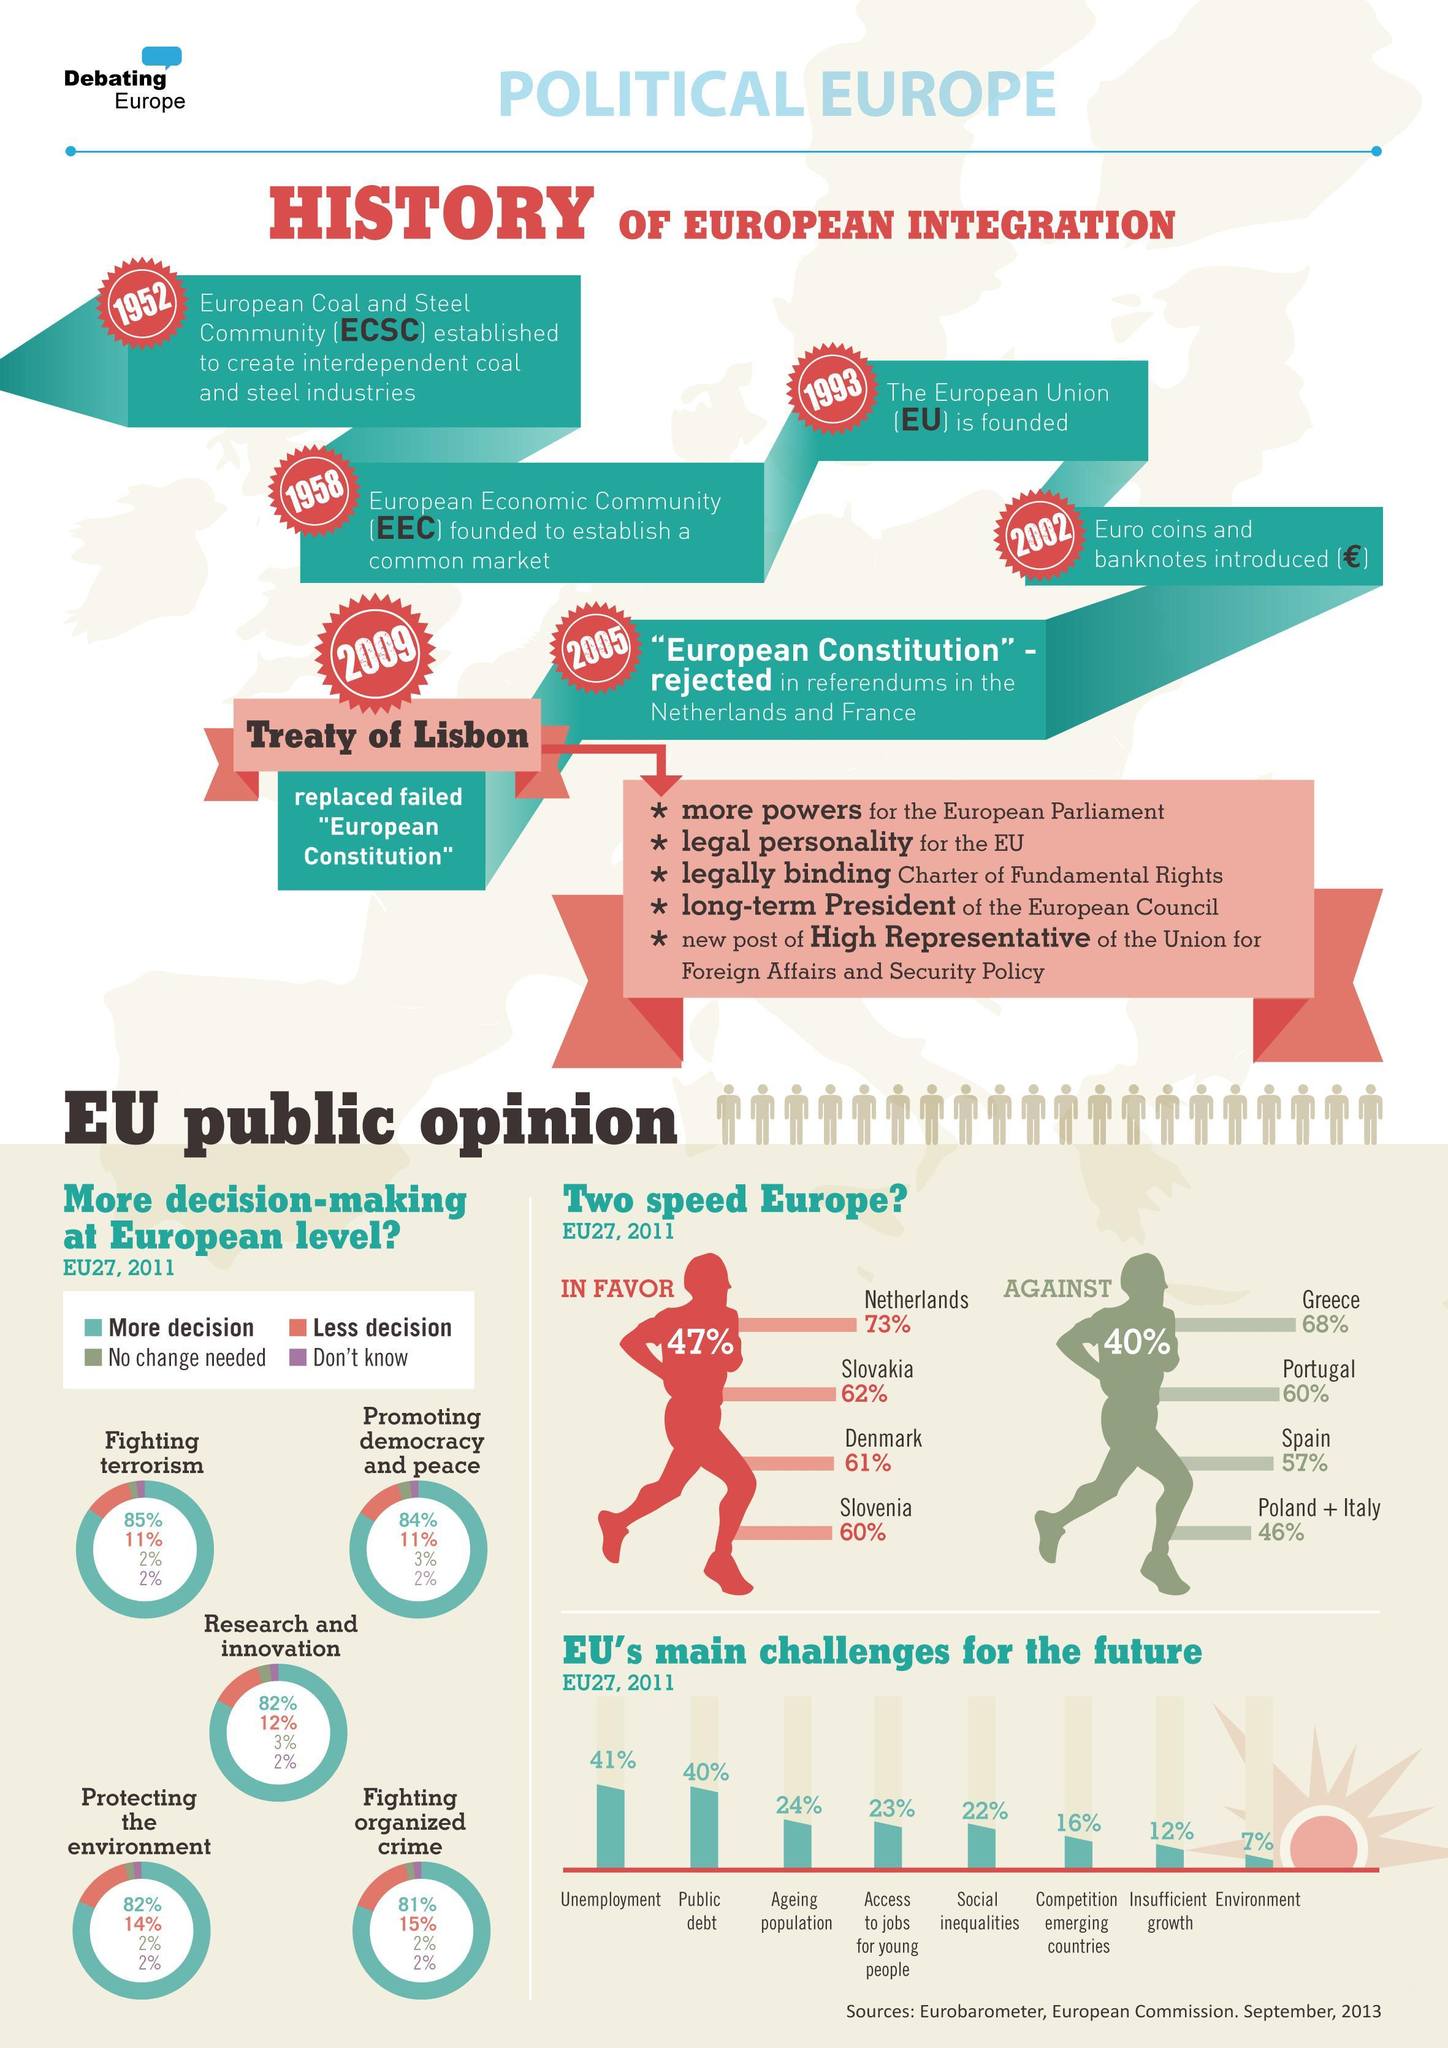How many points in the treaty of Lisbon
Answer the question with a short phrase. 5 What is the first two main challenges for EU for the future Unemployment, Public depot Along with Netherlands, which other countries were in favour of two speed Europe Slovakia, Denmark, Slovenia How many years after establishing the ECSC was the euro coins and bank notes introduced 50 In addition to Poland + Italy, which countries were against the two speed Europe Greece, Portugal, Spain When was the treaty of Lisbon finalised 2009 